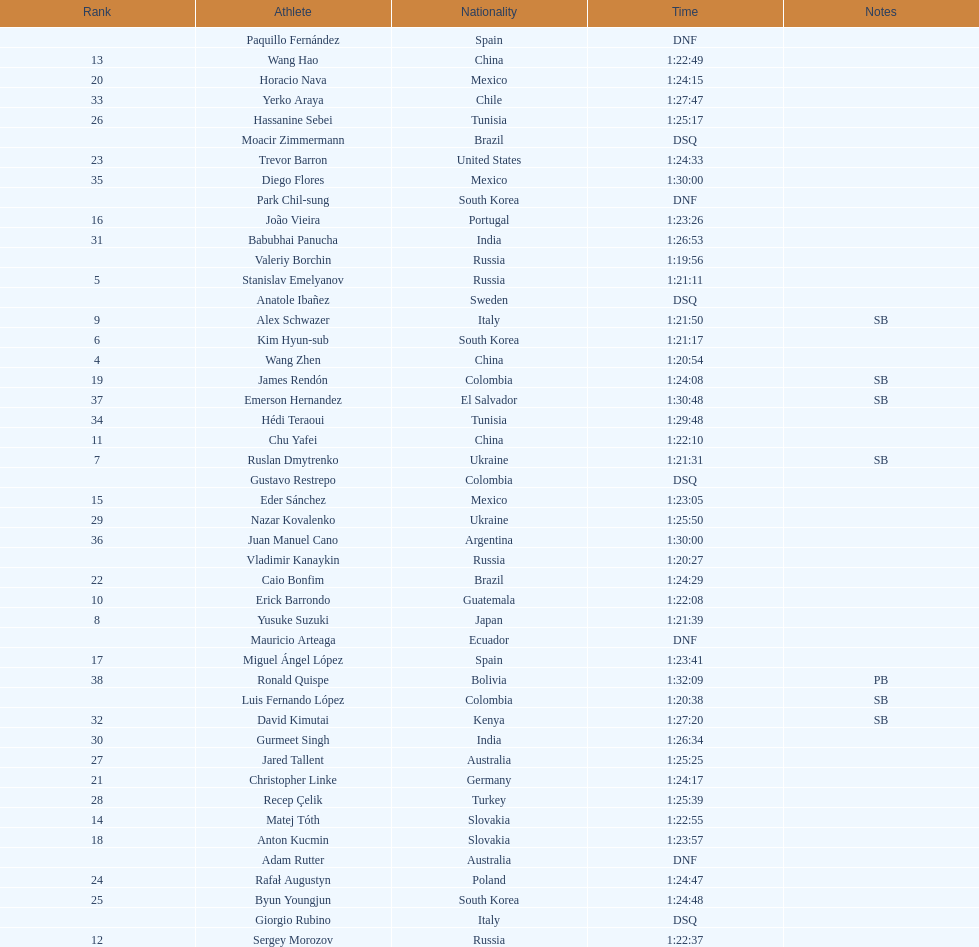How many russians finished at least 3rd in the 20km walk? 2. 